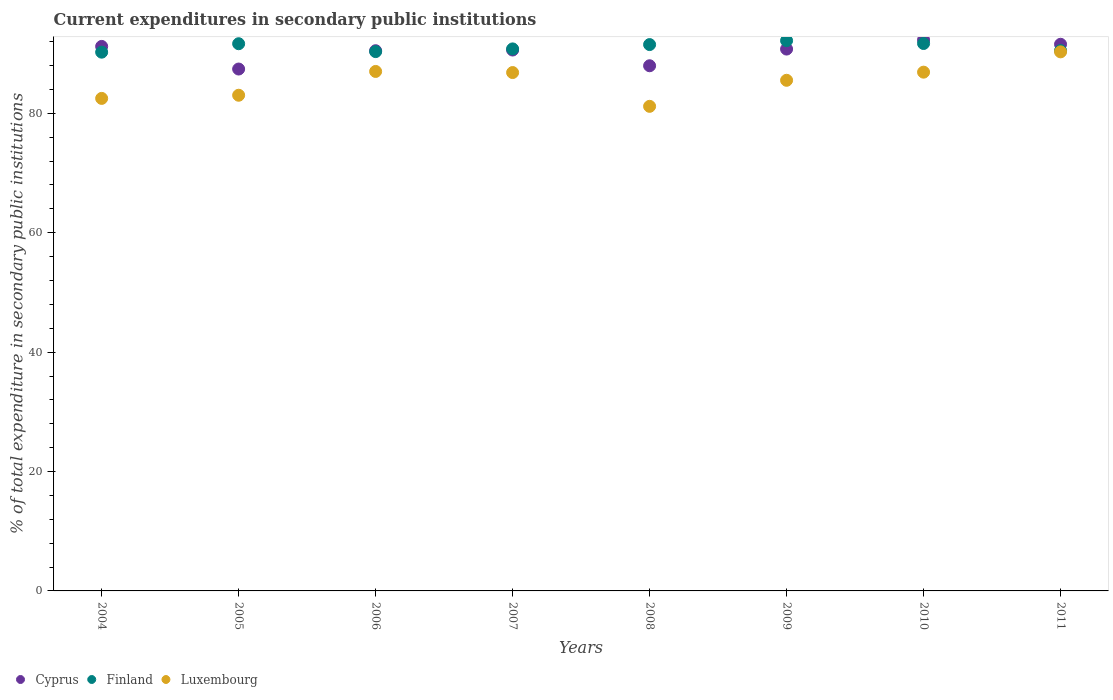Is the number of dotlines equal to the number of legend labels?
Offer a very short reply. Yes. What is the current expenditures in secondary public institutions in Luxembourg in 2008?
Keep it short and to the point. 81.17. Across all years, what is the maximum current expenditures in secondary public institutions in Luxembourg?
Offer a very short reply. 90.3. Across all years, what is the minimum current expenditures in secondary public institutions in Cyprus?
Your response must be concise. 87.42. What is the total current expenditures in secondary public institutions in Luxembourg in the graph?
Your answer should be very brief. 683.26. What is the difference between the current expenditures in secondary public institutions in Cyprus in 2010 and that in 2011?
Ensure brevity in your answer.  0.73. What is the difference between the current expenditures in secondary public institutions in Cyprus in 2004 and the current expenditures in secondary public institutions in Finland in 2009?
Provide a short and direct response. -0.97. What is the average current expenditures in secondary public institutions in Luxembourg per year?
Keep it short and to the point. 85.41. In the year 2005, what is the difference between the current expenditures in secondary public institutions in Finland and current expenditures in secondary public institutions in Luxembourg?
Your answer should be compact. 8.63. What is the ratio of the current expenditures in secondary public institutions in Luxembourg in 2005 to that in 2006?
Make the answer very short. 0.95. Is the difference between the current expenditures in secondary public institutions in Finland in 2004 and 2008 greater than the difference between the current expenditures in secondary public institutions in Luxembourg in 2004 and 2008?
Make the answer very short. No. What is the difference between the highest and the second highest current expenditures in secondary public institutions in Finland?
Provide a short and direct response. 0.48. What is the difference between the highest and the lowest current expenditures in secondary public institutions in Cyprus?
Keep it short and to the point. 4.88. In how many years, is the current expenditures in secondary public institutions in Cyprus greater than the average current expenditures in secondary public institutions in Cyprus taken over all years?
Your answer should be compact. 6. Is the sum of the current expenditures in secondary public institutions in Finland in 2008 and 2010 greater than the maximum current expenditures in secondary public institutions in Cyprus across all years?
Offer a terse response. Yes. Does the current expenditures in secondary public institutions in Cyprus monotonically increase over the years?
Keep it short and to the point. No. Is the current expenditures in secondary public institutions in Cyprus strictly greater than the current expenditures in secondary public institutions in Luxembourg over the years?
Make the answer very short. Yes. What is the difference between two consecutive major ticks on the Y-axis?
Ensure brevity in your answer.  20. Are the values on the major ticks of Y-axis written in scientific E-notation?
Offer a terse response. No. How many legend labels are there?
Your response must be concise. 3. What is the title of the graph?
Provide a short and direct response. Current expenditures in secondary public institutions. Does "Algeria" appear as one of the legend labels in the graph?
Your answer should be compact. No. What is the label or title of the X-axis?
Keep it short and to the point. Years. What is the label or title of the Y-axis?
Offer a terse response. % of total expenditure in secondary public institutions. What is the % of total expenditure in secondary public institutions of Cyprus in 2004?
Offer a terse response. 91.21. What is the % of total expenditure in secondary public institutions in Finland in 2004?
Offer a terse response. 90.24. What is the % of total expenditure in secondary public institutions in Luxembourg in 2004?
Offer a terse response. 82.5. What is the % of total expenditure in secondary public institutions of Cyprus in 2005?
Your answer should be very brief. 87.42. What is the % of total expenditure in secondary public institutions in Finland in 2005?
Ensure brevity in your answer.  91.66. What is the % of total expenditure in secondary public institutions of Luxembourg in 2005?
Your answer should be compact. 83.03. What is the % of total expenditure in secondary public institutions in Cyprus in 2006?
Make the answer very short. 90.49. What is the % of total expenditure in secondary public institutions in Finland in 2006?
Your response must be concise. 90.34. What is the % of total expenditure in secondary public institutions of Luxembourg in 2006?
Keep it short and to the point. 87.01. What is the % of total expenditure in secondary public institutions in Cyprus in 2007?
Ensure brevity in your answer.  90.6. What is the % of total expenditure in secondary public institutions in Finland in 2007?
Your response must be concise. 90.79. What is the % of total expenditure in secondary public institutions in Luxembourg in 2007?
Offer a terse response. 86.83. What is the % of total expenditure in secondary public institutions of Cyprus in 2008?
Keep it short and to the point. 87.97. What is the % of total expenditure in secondary public institutions in Finland in 2008?
Give a very brief answer. 91.51. What is the % of total expenditure in secondary public institutions of Luxembourg in 2008?
Provide a short and direct response. 81.17. What is the % of total expenditure in secondary public institutions in Cyprus in 2009?
Your answer should be compact. 90.76. What is the % of total expenditure in secondary public institutions of Finland in 2009?
Your response must be concise. 92.17. What is the % of total expenditure in secondary public institutions in Luxembourg in 2009?
Ensure brevity in your answer.  85.53. What is the % of total expenditure in secondary public institutions of Cyprus in 2010?
Ensure brevity in your answer.  92.3. What is the % of total expenditure in secondary public institutions in Finland in 2010?
Keep it short and to the point. 91.69. What is the % of total expenditure in secondary public institutions of Luxembourg in 2010?
Your answer should be compact. 86.89. What is the % of total expenditure in secondary public institutions in Cyprus in 2011?
Provide a succinct answer. 91.57. What is the % of total expenditure in secondary public institutions of Finland in 2011?
Provide a short and direct response. 90.51. What is the % of total expenditure in secondary public institutions in Luxembourg in 2011?
Give a very brief answer. 90.3. Across all years, what is the maximum % of total expenditure in secondary public institutions of Cyprus?
Offer a terse response. 92.3. Across all years, what is the maximum % of total expenditure in secondary public institutions of Finland?
Your answer should be compact. 92.17. Across all years, what is the maximum % of total expenditure in secondary public institutions of Luxembourg?
Ensure brevity in your answer.  90.3. Across all years, what is the minimum % of total expenditure in secondary public institutions in Cyprus?
Your answer should be very brief. 87.42. Across all years, what is the minimum % of total expenditure in secondary public institutions of Finland?
Provide a succinct answer. 90.24. Across all years, what is the minimum % of total expenditure in secondary public institutions in Luxembourg?
Offer a very short reply. 81.17. What is the total % of total expenditure in secondary public institutions in Cyprus in the graph?
Offer a very short reply. 722.3. What is the total % of total expenditure in secondary public institutions of Finland in the graph?
Offer a very short reply. 728.92. What is the total % of total expenditure in secondary public institutions in Luxembourg in the graph?
Your response must be concise. 683.26. What is the difference between the % of total expenditure in secondary public institutions of Cyprus in 2004 and that in 2005?
Your answer should be very brief. 3.79. What is the difference between the % of total expenditure in secondary public institutions of Finland in 2004 and that in 2005?
Offer a very short reply. -1.41. What is the difference between the % of total expenditure in secondary public institutions of Luxembourg in 2004 and that in 2005?
Keep it short and to the point. -0.53. What is the difference between the % of total expenditure in secondary public institutions of Cyprus in 2004 and that in 2006?
Ensure brevity in your answer.  0.72. What is the difference between the % of total expenditure in secondary public institutions of Finland in 2004 and that in 2006?
Your answer should be very brief. -0.09. What is the difference between the % of total expenditure in secondary public institutions in Luxembourg in 2004 and that in 2006?
Offer a very short reply. -4.51. What is the difference between the % of total expenditure in secondary public institutions in Cyprus in 2004 and that in 2007?
Provide a succinct answer. 0.6. What is the difference between the % of total expenditure in secondary public institutions in Finland in 2004 and that in 2007?
Keep it short and to the point. -0.55. What is the difference between the % of total expenditure in secondary public institutions in Luxembourg in 2004 and that in 2007?
Your response must be concise. -4.33. What is the difference between the % of total expenditure in secondary public institutions of Cyprus in 2004 and that in 2008?
Your response must be concise. 3.24. What is the difference between the % of total expenditure in secondary public institutions of Finland in 2004 and that in 2008?
Offer a very short reply. -1.27. What is the difference between the % of total expenditure in secondary public institutions in Luxembourg in 2004 and that in 2008?
Provide a short and direct response. 1.33. What is the difference between the % of total expenditure in secondary public institutions in Cyprus in 2004 and that in 2009?
Keep it short and to the point. 0.44. What is the difference between the % of total expenditure in secondary public institutions of Finland in 2004 and that in 2009?
Offer a terse response. -1.93. What is the difference between the % of total expenditure in secondary public institutions of Luxembourg in 2004 and that in 2009?
Your answer should be compact. -3.03. What is the difference between the % of total expenditure in secondary public institutions of Cyprus in 2004 and that in 2010?
Your response must be concise. -1.09. What is the difference between the % of total expenditure in secondary public institutions in Finland in 2004 and that in 2010?
Your answer should be very brief. -1.45. What is the difference between the % of total expenditure in secondary public institutions of Luxembourg in 2004 and that in 2010?
Make the answer very short. -4.4. What is the difference between the % of total expenditure in secondary public institutions in Cyprus in 2004 and that in 2011?
Ensure brevity in your answer.  -0.36. What is the difference between the % of total expenditure in secondary public institutions in Finland in 2004 and that in 2011?
Your answer should be very brief. -0.27. What is the difference between the % of total expenditure in secondary public institutions of Luxembourg in 2004 and that in 2011?
Your answer should be very brief. -7.8. What is the difference between the % of total expenditure in secondary public institutions in Cyprus in 2005 and that in 2006?
Make the answer very short. -3.07. What is the difference between the % of total expenditure in secondary public institutions of Finland in 2005 and that in 2006?
Provide a succinct answer. 1.32. What is the difference between the % of total expenditure in secondary public institutions of Luxembourg in 2005 and that in 2006?
Keep it short and to the point. -3.99. What is the difference between the % of total expenditure in secondary public institutions of Cyprus in 2005 and that in 2007?
Your answer should be compact. -3.18. What is the difference between the % of total expenditure in secondary public institutions of Finland in 2005 and that in 2007?
Ensure brevity in your answer.  0.87. What is the difference between the % of total expenditure in secondary public institutions of Luxembourg in 2005 and that in 2007?
Offer a terse response. -3.8. What is the difference between the % of total expenditure in secondary public institutions of Cyprus in 2005 and that in 2008?
Offer a very short reply. -0.55. What is the difference between the % of total expenditure in secondary public institutions of Finland in 2005 and that in 2008?
Provide a short and direct response. 0.14. What is the difference between the % of total expenditure in secondary public institutions in Luxembourg in 2005 and that in 2008?
Ensure brevity in your answer.  1.86. What is the difference between the % of total expenditure in secondary public institutions in Cyprus in 2005 and that in 2009?
Your answer should be compact. -3.34. What is the difference between the % of total expenditure in secondary public institutions in Finland in 2005 and that in 2009?
Your answer should be compact. -0.52. What is the difference between the % of total expenditure in secondary public institutions in Luxembourg in 2005 and that in 2009?
Your answer should be compact. -2.5. What is the difference between the % of total expenditure in secondary public institutions in Cyprus in 2005 and that in 2010?
Your answer should be compact. -4.88. What is the difference between the % of total expenditure in secondary public institutions in Finland in 2005 and that in 2010?
Offer a terse response. -0.04. What is the difference between the % of total expenditure in secondary public institutions in Luxembourg in 2005 and that in 2010?
Keep it short and to the point. -3.87. What is the difference between the % of total expenditure in secondary public institutions of Cyprus in 2005 and that in 2011?
Keep it short and to the point. -4.15. What is the difference between the % of total expenditure in secondary public institutions of Finland in 2005 and that in 2011?
Offer a terse response. 1.15. What is the difference between the % of total expenditure in secondary public institutions in Luxembourg in 2005 and that in 2011?
Your answer should be compact. -7.27. What is the difference between the % of total expenditure in secondary public institutions in Cyprus in 2006 and that in 2007?
Ensure brevity in your answer.  -0.11. What is the difference between the % of total expenditure in secondary public institutions in Finland in 2006 and that in 2007?
Your answer should be compact. -0.45. What is the difference between the % of total expenditure in secondary public institutions of Luxembourg in 2006 and that in 2007?
Ensure brevity in your answer.  0.19. What is the difference between the % of total expenditure in secondary public institutions of Cyprus in 2006 and that in 2008?
Give a very brief answer. 2.52. What is the difference between the % of total expenditure in secondary public institutions in Finland in 2006 and that in 2008?
Keep it short and to the point. -1.18. What is the difference between the % of total expenditure in secondary public institutions of Luxembourg in 2006 and that in 2008?
Give a very brief answer. 5.84. What is the difference between the % of total expenditure in secondary public institutions of Cyprus in 2006 and that in 2009?
Provide a short and direct response. -0.28. What is the difference between the % of total expenditure in secondary public institutions in Finland in 2006 and that in 2009?
Provide a succinct answer. -1.84. What is the difference between the % of total expenditure in secondary public institutions in Luxembourg in 2006 and that in 2009?
Offer a terse response. 1.48. What is the difference between the % of total expenditure in secondary public institutions in Cyprus in 2006 and that in 2010?
Your response must be concise. -1.81. What is the difference between the % of total expenditure in secondary public institutions of Finland in 2006 and that in 2010?
Your response must be concise. -1.36. What is the difference between the % of total expenditure in secondary public institutions in Luxembourg in 2006 and that in 2010?
Give a very brief answer. 0.12. What is the difference between the % of total expenditure in secondary public institutions in Cyprus in 2006 and that in 2011?
Your answer should be compact. -1.08. What is the difference between the % of total expenditure in secondary public institutions in Finland in 2006 and that in 2011?
Your response must be concise. -0.18. What is the difference between the % of total expenditure in secondary public institutions in Luxembourg in 2006 and that in 2011?
Provide a short and direct response. -3.28. What is the difference between the % of total expenditure in secondary public institutions in Cyprus in 2007 and that in 2008?
Ensure brevity in your answer.  2.64. What is the difference between the % of total expenditure in secondary public institutions in Finland in 2007 and that in 2008?
Provide a short and direct response. -0.72. What is the difference between the % of total expenditure in secondary public institutions in Luxembourg in 2007 and that in 2008?
Your answer should be compact. 5.66. What is the difference between the % of total expenditure in secondary public institutions of Cyprus in 2007 and that in 2009?
Offer a terse response. -0.16. What is the difference between the % of total expenditure in secondary public institutions of Finland in 2007 and that in 2009?
Offer a terse response. -1.38. What is the difference between the % of total expenditure in secondary public institutions of Luxembourg in 2007 and that in 2009?
Keep it short and to the point. 1.29. What is the difference between the % of total expenditure in secondary public institutions in Cyprus in 2007 and that in 2010?
Make the answer very short. -1.7. What is the difference between the % of total expenditure in secondary public institutions of Finland in 2007 and that in 2010?
Your answer should be very brief. -0.9. What is the difference between the % of total expenditure in secondary public institutions in Luxembourg in 2007 and that in 2010?
Provide a short and direct response. -0.07. What is the difference between the % of total expenditure in secondary public institutions in Cyprus in 2007 and that in 2011?
Ensure brevity in your answer.  -0.96. What is the difference between the % of total expenditure in secondary public institutions in Finland in 2007 and that in 2011?
Make the answer very short. 0.28. What is the difference between the % of total expenditure in secondary public institutions of Luxembourg in 2007 and that in 2011?
Make the answer very short. -3.47. What is the difference between the % of total expenditure in secondary public institutions of Cyprus in 2008 and that in 2009?
Make the answer very short. -2.8. What is the difference between the % of total expenditure in secondary public institutions of Finland in 2008 and that in 2009?
Keep it short and to the point. -0.66. What is the difference between the % of total expenditure in secondary public institutions in Luxembourg in 2008 and that in 2009?
Keep it short and to the point. -4.36. What is the difference between the % of total expenditure in secondary public institutions in Cyprus in 2008 and that in 2010?
Provide a succinct answer. -4.33. What is the difference between the % of total expenditure in secondary public institutions in Finland in 2008 and that in 2010?
Make the answer very short. -0.18. What is the difference between the % of total expenditure in secondary public institutions of Luxembourg in 2008 and that in 2010?
Provide a succinct answer. -5.72. What is the difference between the % of total expenditure in secondary public institutions of Cyprus in 2008 and that in 2011?
Make the answer very short. -3.6. What is the difference between the % of total expenditure in secondary public institutions in Luxembourg in 2008 and that in 2011?
Your answer should be very brief. -9.12. What is the difference between the % of total expenditure in secondary public institutions in Cyprus in 2009 and that in 2010?
Provide a succinct answer. -1.54. What is the difference between the % of total expenditure in secondary public institutions in Finland in 2009 and that in 2010?
Keep it short and to the point. 0.48. What is the difference between the % of total expenditure in secondary public institutions of Luxembourg in 2009 and that in 2010?
Your answer should be compact. -1.36. What is the difference between the % of total expenditure in secondary public institutions in Cyprus in 2009 and that in 2011?
Your answer should be very brief. -0.8. What is the difference between the % of total expenditure in secondary public institutions of Finland in 2009 and that in 2011?
Your response must be concise. 1.66. What is the difference between the % of total expenditure in secondary public institutions in Luxembourg in 2009 and that in 2011?
Ensure brevity in your answer.  -4.76. What is the difference between the % of total expenditure in secondary public institutions of Cyprus in 2010 and that in 2011?
Give a very brief answer. 0.73. What is the difference between the % of total expenditure in secondary public institutions in Finland in 2010 and that in 2011?
Offer a terse response. 1.18. What is the difference between the % of total expenditure in secondary public institutions in Luxembourg in 2010 and that in 2011?
Keep it short and to the point. -3.4. What is the difference between the % of total expenditure in secondary public institutions in Cyprus in 2004 and the % of total expenditure in secondary public institutions in Finland in 2005?
Make the answer very short. -0.45. What is the difference between the % of total expenditure in secondary public institutions in Cyprus in 2004 and the % of total expenditure in secondary public institutions in Luxembourg in 2005?
Your answer should be compact. 8.18. What is the difference between the % of total expenditure in secondary public institutions of Finland in 2004 and the % of total expenditure in secondary public institutions of Luxembourg in 2005?
Keep it short and to the point. 7.22. What is the difference between the % of total expenditure in secondary public institutions of Cyprus in 2004 and the % of total expenditure in secondary public institutions of Finland in 2006?
Your answer should be very brief. 0.87. What is the difference between the % of total expenditure in secondary public institutions of Cyprus in 2004 and the % of total expenditure in secondary public institutions of Luxembourg in 2006?
Provide a succinct answer. 4.19. What is the difference between the % of total expenditure in secondary public institutions in Finland in 2004 and the % of total expenditure in secondary public institutions in Luxembourg in 2006?
Provide a succinct answer. 3.23. What is the difference between the % of total expenditure in secondary public institutions in Cyprus in 2004 and the % of total expenditure in secondary public institutions in Finland in 2007?
Your response must be concise. 0.42. What is the difference between the % of total expenditure in secondary public institutions in Cyprus in 2004 and the % of total expenditure in secondary public institutions in Luxembourg in 2007?
Make the answer very short. 4.38. What is the difference between the % of total expenditure in secondary public institutions in Finland in 2004 and the % of total expenditure in secondary public institutions in Luxembourg in 2007?
Provide a succinct answer. 3.42. What is the difference between the % of total expenditure in secondary public institutions of Cyprus in 2004 and the % of total expenditure in secondary public institutions of Finland in 2008?
Make the answer very short. -0.31. What is the difference between the % of total expenditure in secondary public institutions of Cyprus in 2004 and the % of total expenditure in secondary public institutions of Luxembourg in 2008?
Ensure brevity in your answer.  10.04. What is the difference between the % of total expenditure in secondary public institutions in Finland in 2004 and the % of total expenditure in secondary public institutions in Luxembourg in 2008?
Give a very brief answer. 9.07. What is the difference between the % of total expenditure in secondary public institutions of Cyprus in 2004 and the % of total expenditure in secondary public institutions of Finland in 2009?
Your answer should be very brief. -0.97. What is the difference between the % of total expenditure in secondary public institutions of Cyprus in 2004 and the % of total expenditure in secondary public institutions of Luxembourg in 2009?
Make the answer very short. 5.67. What is the difference between the % of total expenditure in secondary public institutions in Finland in 2004 and the % of total expenditure in secondary public institutions in Luxembourg in 2009?
Your response must be concise. 4.71. What is the difference between the % of total expenditure in secondary public institutions of Cyprus in 2004 and the % of total expenditure in secondary public institutions of Finland in 2010?
Provide a succinct answer. -0.49. What is the difference between the % of total expenditure in secondary public institutions of Cyprus in 2004 and the % of total expenditure in secondary public institutions of Luxembourg in 2010?
Provide a short and direct response. 4.31. What is the difference between the % of total expenditure in secondary public institutions in Finland in 2004 and the % of total expenditure in secondary public institutions in Luxembourg in 2010?
Provide a succinct answer. 3.35. What is the difference between the % of total expenditure in secondary public institutions in Cyprus in 2004 and the % of total expenditure in secondary public institutions in Finland in 2011?
Ensure brevity in your answer.  0.69. What is the difference between the % of total expenditure in secondary public institutions of Cyprus in 2004 and the % of total expenditure in secondary public institutions of Luxembourg in 2011?
Make the answer very short. 0.91. What is the difference between the % of total expenditure in secondary public institutions of Finland in 2004 and the % of total expenditure in secondary public institutions of Luxembourg in 2011?
Provide a short and direct response. -0.05. What is the difference between the % of total expenditure in secondary public institutions in Cyprus in 2005 and the % of total expenditure in secondary public institutions in Finland in 2006?
Provide a succinct answer. -2.92. What is the difference between the % of total expenditure in secondary public institutions of Cyprus in 2005 and the % of total expenditure in secondary public institutions of Luxembourg in 2006?
Ensure brevity in your answer.  0.4. What is the difference between the % of total expenditure in secondary public institutions of Finland in 2005 and the % of total expenditure in secondary public institutions of Luxembourg in 2006?
Provide a short and direct response. 4.64. What is the difference between the % of total expenditure in secondary public institutions in Cyprus in 2005 and the % of total expenditure in secondary public institutions in Finland in 2007?
Offer a terse response. -3.37. What is the difference between the % of total expenditure in secondary public institutions of Cyprus in 2005 and the % of total expenditure in secondary public institutions of Luxembourg in 2007?
Your answer should be compact. 0.59. What is the difference between the % of total expenditure in secondary public institutions in Finland in 2005 and the % of total expenditure in secondary public institutions in Luxembourg in 2007?
Give a very brief answer. 4.83. What is the difference between the % of total expenditure in secondary public institutions of Cyprus in 2005 and the % of total expenditure in secondary public institutions of Finland in 2008?
Offer a very short reply. -4.1. What is the difference between the % of total expenditure in secondary public institutions in Cyprus in 2005 and the % of total expenditure in secondary public institutions in Luxembourg in 2008?
Offer a terse response. 6.25. What is the difference between the % of total expenditure in secondary public institutions in Finland in 2005 and the % of total expenditure in secondary public institutions in Luxembourg in 2008?
Your answer should be compact. 10.49. What is the difference between the % of total expenditure in secondary public institutions of Cyprus in 2005 and the % of total expenditure in secondary public institutions of Finland in 2009?
Your response must be concise. -4.75. What is the difference between the % of total expenditure in secondary public institutions of Cyprus in 2005 and the % of total expenditure in secondary public institutions of Luxembourg in 2009?
Offer a very short reply. 1.89. What is the difference between the % of total expenditure in secondary public institutions in Finland in 2005 and the % of total expenditure in secondary public institutions in Luxembourg in 2009?
Make the answer very short. 6.12. What is the difference between the % of total expenditure in secondary public institutions in Cyprus in 2005 and the % of total expenditure in secondary public institutions in Finland in 2010?
Provide a short and direct response. -4.28. What is the difference between the % of total expenditure in secondary public institutions of Cyprus in 2005 and the % of total expenditure in secondary public institutions of Luxembourg in 2010?
Your response must be concise. 0.52. What is the difference between the % of total expenditure in secondary public institutions in Finland in 2005 and the % of total expenditure in secondary public institutions in Luxembourg in 2010?
Keep it short and to the point. 4.76. What is the difference between the % of total expenditure in secondary public institutions in Cyprus in 2005 and the % of total expenditure in secondary public institutions in Finland in 2011?
Provide a succinct answer. -3.09. What is the difference between the % of total expenditure in secondary public institutions in Cyprus in 2005 and the % of total expenditure in secondary public institutions in Luxembourg in 2011?
Your response must be concise. -2.88. What is the difference between the % of total expenditure in secondary public institutions of Finland in 2005 and the % of total expenditure in secondary public institutions of Luxembourg in 2011?
Ensure brevity in your answer.  1.36. What is the difference between the % of total expenditure in secondary public institutions of Cyprus in 2006 and the % of total expenditure in secondary public institutions of Finland in 2007?
Keep it short and to the point. -0.3. What is the difference between the % of total expenditure in secondary public institutions of Cyprus in 2006 and the % of total expenditure in secondary public institutions of Luxembourg in 2007?
Offer a terse response. 3.66. What is the difference between the % of total expenditure in secondary public institutions of Finland in 2006 and the % of total expenditure in secondary public institutions of Luxembourg in 2007?
Your response must be concise. 3.51. What is the difference between the % of total expenditure in secondary public institutions in Cyprus in 2006 and the % of total expenditure in secondary public institutions in Finland in 2008?
Ensure brevity in your answer.  -1.03. What is the difference between the % of total expenditure in secondary public institutions in Cyprus in 2006 and the % of total expenditure in secondary public institutions in Luxembourg in 2008?
Make the answer very short. 9.32. What is the difference between the % of total expenditure in secondary public institutions of Finland in 2006 and the % of total expenditure in secondary public institutions of Luxembourg in 2008?
Give a very brief answer. 9.17. What is the difference between the % of total expenditure in secondary public institutions of Cyprus in 2006 and the % of total expenditure in secondary public institutions of Finland in 2009?
Offer a very short reply. -1.69. What is the difference between the % of total expenditure in secondary public institutions in Cyprus in 2006 and the % of total expenditure in secondary public institutions in Luxembourg in 2009?
Give a very brief answer. 4.95. What is the difference between the % of total expenditure in secondary public institutions in Finland in 2006 and the % of total expenditure in secondary public institutions in Luxembourg in 2009?
Your answer should be very brief. 4.8. What is the difference between the % of total expenditure in secondary public institutions in Cyprus in 2006 and the % of total expenditure in secondary public institutions in Finland in 2010?
Provide a succinct answer. -1.21. What is the difference between the % of total expenditure in secondary public institutions in Cyprus in 2006 and the % of total expenditure in secondary public institutions in Luxembourg in 2010?
Make the answer very short. 3.59. What is the difference between the % of total expenditure in secondary public institutions in Finland in 2006 and the % of total expenditure in secondary public institutions in Luxembourg in 2010?
Offer a very short reply. 3.44. What is the difference between the % of total expenditure in secondary public institutions of Cyprus in 2006 and the % of total expenditure in secondary public institutions of Finland in 2011?
Your answer should be very brief. -0.03. What is the difference between the % of total expenditure in secondary public institutions of Cyprus in 2006 and the % of total expenditure in secondary public institutions of Luxembourg in 2011?
Keep it short and to the point. 0.19. What is the difference between the % of total expenditure in secondary public institutions in Finland in 2006 and the % of total expenditure in secondary public institutions in Luxembourg in 2011?
Your answer should be very brief. 0.04. What is the difference between the % of total expenditure in secondary public institutions in Cyprus in 2007 and the % of total expenditure in secondary public institutions in Finland in 2008?
Ensure brevity in your answer.  -0.91. What is the difference between the % of total expenditure in secondary public institutions in Cyprus in 2007 and the % of total expenditure in secondary public institutions in Luxembourg in 2008?
Provide a short and direct response. 9.43. What is the difference between the % of total expenditure in secondary public institutions of Finland in 2007 and the % of total expenditure in secondary public institutions of Luxembourg in 2008?
Your answer should be very brief. 9.62. What is the difference between the % of total expenditure in secondary public institutions of Cyprus in 2007 and the % of total expenditure in secondary public institutions of Finland in 2009?
Give a very brief answer. -1.57. What is the difference between the % of total expenditure in secondary public institutions in Cyprus in 2007 and the % of total expenditure in secondary public institutions in Luxembourg in 2009?
Give a very brief answer. 5.07. What is the difference between the % of total expenditure in secondary public institutions of Finland in 2007 and the % of total expenditure in secondary public institutions of Luxembourg in 2009?
Offer a very short reply. 5.26. What is the difference between the % of total expenditure in secondary public institutions of Cyprus in 2007 and the % of total expenditure in secondary public institutions of Finland in 2010?
Offer a very short reply. -1.09. What is the difference between the % of total expenditure in secondary public institutions of Cyprus in 2007 and the % of total expenditure in secondary public institutions of Luxembourg in 2010?
Provide a short and direct response. 3.71. What is the difference between the % of total expenditure in secondary public institutions of Finland in 2007 and the % of total expenditure in secondary public institutions of Luxembourg in 2010?
Provide a short and direct response. 3.9. What is the difference between the % of total expenditure in secondary public institutions in Cyprus in 2007 and the % of total expenditure in secondary public institutions in Finland in 2011?
Offer a terse response. 0.09. What is the difference between the % of total expenditure in secondary public institutions of Cyprus in 2007 and the % of total expenditure in secondary public institutions of Luxembourg in 2011?
Provide a short and direct response. 0.31. What is the difference between the % of total expenditure in secondary public institutions of Finland in 2007 and the % of total expenditure in secondary public institutions of Luxembourg in 2011?
Your response must be concise. 0.49. What is the difference between the % of total expenditure in secondary public institutions of Cyprus in 2008 and the % of total expenditure in secondary public institutions of Finland in 2009?
Your answer should be very brief. -4.21. What is the difference between the % of total expenditure in secondary public institutions in Cyprus in 2008 and the % of total expenditure in secondary public institutions in Luxembourg in 2009?
Make the answer very short. 2.43. What is the difference between the % of total expenditure in secondary public institutions of Finland in 2008 and the % of total expenditure in secondary public institutions of Luxembourg in 2009?
Offer a very short reply. 5.98. What is the difference between the % of total expenditure in secondary public institutions in Cyprus in 2008 and the % of total expenditure in secondary public institutions in Finland in 2010?
Your answer should be very brief. -3.73. What is the difference between the % of total expenditure in secondary public institutions in Cyprus in 2008 and the % of total expenditure in secondary public institutions in Luxembourg in 2010?
Your answer should be compact. 1.07. What is the difference between the % of total expenditure in secondary public institutions in Finland in 2008 and the % of total expenditure in secondary public institutions in Luxembourg in 2010?
Your answer should be very brief. 4.62. What is the difference between the % of total expenditure in secondary public institutions in Cyprus in 2008 and the % of total expenditure in secondary public institutions in Finland in 2011?
Provide a succinct answer. -2.55. What is the difference between the % of total expenditure in secondary public institutions of Cyprus in 2008 and the % of total expenditure in secondary public institutions of Luxembourg in 2011?
Give a very brief answer. -2.33. What is the difference between the % of total expenditure in secondary public institutions of Finland in 2008 and the % of total expenditure in secondary public institutions of Luxembourg in 2011?
Keep it short and to the point. 1.22. What is the difference between the % of total expenditure in secondary public institutions in Cyprus in 2009 and the % of total expenditure in secondary public institutions in Finland in 2010?
Keep it short and to the point. -0.93. What is the difference between the % of total expenditure in secondary public institutions of Cyprus in 2009 and the % of total expenditure in secondary public institutions of Luxembourg in 2010?
Offer a terse response. 3.87. What is the difference between the % of total expenditure in secondary public institutions of Finland in 2009 and the % of total expenditure in secondary public institutions of Luxembourg in 2010?
Your answer should be very brief. 5.28. What is the difference between the % of total expenditure in secondary public institutions in Cyprus in 2009 and the % of total expenditure in secondary public institutions in Finland in 2011?
Your answer should be very brief. 0.25. What is the difference between the % of total expenditure in secondary public institutions in Cyprus in 2009 and the % of total expenditure in secondary public institutions in Luxembourg in 2011?
Keep it short and to the point. 0.47. What is the difference between the % of total expenditure in secondary public institutions of Finland in 2009 and the % of total expenditure in secondary public institutions of Luxembourg in 2011?
Your response must be concise. 1.88. What is the difference between the % of total expenditure in secondary public institutions of Cyprus in 2010 and the % of total expenditure in secondary public institutions of Finland in 2011?
Provide a succinct answer. 1.79. What is the difference between the % of total expenditure in secondary public institutions in Cyprus in 2010 and the % of total expenditure in secondary public institutions in Luxembourg in 2011?
Provide a succinct answer. 2. What is the difference between the % of total expenditure in secondary public institutions in Finland in 2010 and the % of total expenditure in secondary public institutions in Luxembourg in 2011?
Your answer should be compact. 1.4. What is the average % of total expenditure in secondary public institutions of Cyprus per year?
Keep it short and to the point. 90.29. What is the average % of total expenditure in secondary public institutions in Finland per year?
Make the answer very short. 91.12. What is the average % of total expenditure in secondary public institutions in Luxembourg per year?
Make the answer very short. 85.41. In the year 2004, what is the difference between the % of total expenditure in secondary public institutions of Cyprus and % of total expenditure in secondary public institutions of Finland?
Your answer should be very brief. 0.96. In the year 2004, what is the difference between the % of total expenditure in secondary public institutions in Cyprus and % of total expenditure in secondary public institutions in Luxembourg?
Offer a terse response. 8.71. In the year 2004, what is the difference between the % of total expenditure in secondary public institutions in Finland and % of total expenditure in secondary public institutions in Luxembourg?
Your answer should be compact. 7.74. In the year 2005, what is the difference between the % of total expenditure in secondary public institutions in Cyprus and % of total expenditure in secondary public institutions in Finland?
Make the answer very short. -4.24. In the year 2005, what is the difference between the % of total expenditure in secondary public institutions in Cyprus and % of total expenditure in secondary public institutions in Luxembourg?
Your response must be concise. 4.39. In the year 2005, what is the difference between the % of total expenditure in secondary public institutions of Finland and % of total expenditure in secondary public institutions of Luxembourg?
Your response must be concise. 8.63. In the year 2006, what is the difference between the % of total expenditure in secondary public institutions in Cyprus and % of total expenditure in secondary public institutions in Finland?
Make the answer very short. 0.15. In the year 2006, what is the difference between the % of total expenditure in secondary public institutions of Cyprus and % of total expenditure in secondary public institutions of Luxembourg?
Make the answer very short. 3.47. In the year 2006, what is the difference between the % of total expenditure in secondary public institutions of Finland and % of total expenditure in secondary public institutions of Luxembourg?
Provide a short and direct response. 3.32. In the year 2007, what is the difference between the % of total expenditure in secondary public institutions in Cyprus and % of total expenditure in secondary public institutions in Finland?
Give a very brief answer. -0.19. In the year 2007, what is the difference between the % of total expenditure in secondary public institutions of Cyprus and % of total expenditure in secondary public institutions of Luxembourg?
Ensure brevity in your answer.  3.77. In the year 2007, what is the difference between the % of total expenditure in secondary public institutions in Finland and % of total expenditure in secondary public institutions in Luxembourg?
Make the answer very short. 3.96. In the year 2008, what is the difference between the % of total expenditure in secondary public institutions of Cyprus and % of total expenditure in secondary public institutions of Finland?
Give a very brief answer. -3.55. In the year 2008, what is the difference between the % of total expenditure in secondary public institutions of Cyprus and % of total expenditure in secondary public institutions of Luxembourg?
Your response must be concise. 6.8. In the year 2008, what is the difference between the % of total expenditure in secondary public institutions in Finland and % of total expenditure in secondary public institutions in Luxembourg?
Make the answer very short. 10.34. In the year 2009, what is the difference between the % of total expenditure in secondary public institutions in Cyprus and % of total expenditure in secondary public institutions in Finland?
Make the answer very short. -1.41. In the year 2009, what is the difference between the % of total expenditure in secondary public institutions of Cyprus and % of total expenditure in secondary public institutions of Luxembourg?
Your answer should be compact. 5.23. In the year 2009, what is the difference between the % of total expenditure in secondary public institutions in Finland and % of total expenditure in secondary public institutions in Luxembourg?
Make the answer very short. 6.64. In the year 2010, what is the difference between the % of total expenditure in secondary public institutions in Cyprus and % of total expenditure in secondary public institutions in Finland?
Your answer should be compact. 0.6. In the year 2010, what is the difference between the % of total expenditure in secondary public institutions in Cyprus and % of total expenditure in secondary public institutions in Luxembourg?
Ensure brevity in your answer.  5.4. In the year 2010, what is the difference between the % of total expenditure in secondary public institutions in Finland and % of total expenditure in secondary public institutions in Luxembourg?
Your response must be concise. 4.8. In the year 2011, what is the difference between the % of total expenditure in secondary public institutions of Cyprus and % of total expenditure in secondary public institutions of Finland?
Provide a succinct answer. 1.05. In the year 2011, what is the difference between the % of total expenditure in secondary public institutions of Cyprus and % of total expenditure in secondary public institutions of Luxembourg?
Keep it short and to the point. 1.27. In the year 2011, what is the difference between the % of total expenditure in secondary public institutions in Finland and % of total expenditure in secondary public institutions in Luxembourg?
Your answer should be very brief. 0.22. What is the ratio of the % of total expenditure in secondary public institutions of Cyprus in 2004 to that in 2005?
Provide a succinct answer. 1.04. What is the ratio of the % of total expenditure in secondary public institutions of Finland in 2004 to that in 2005?
Offer a terse response. 0.98. What is the ratio of the % of total expenditure in secondary public institutions of Luxembourg in 2004 to that in 2005?
Make the answer very short. 0.99. What is the ratio of the % of total expenditure in secondary public institutions of Cyprus in 2004 to that in 2006?
Offer a terse response. 1.01. What is the ratio of the % of total expenditure in secondary public institutions of Luxembourg in 2004 to that in 2006?
Provide a succinct answer. 0.95. What is the ratio of the % of total expenditure in secondary public institutions of Cyprus in 2004 to that in 2007?
Provide a succinct answer. 1.01. What is the ratio of the % of total expenditure in secondary public institutions of Finland in 2004 to that in 2007?
Your response must be concise. 0.99. What is the ratio of the % of total expenditure in secondary public institutions in Luxembourg in 2004 to that in 2007?
Offer a terse response. 0.95. What is the ratio of the % of total expenditure in secondary public institutions of Cyprus in 2004 to that in 2008?
Make the answer very short. 1.04. What is the ratio of the % of total expenditure in secondary public institutions in Finland in 2004 to that in 2008?
Provide a short and direct response. 0.99. What is the ratio of the % of total expenditure in secondary public institutions in Luxembourg in 2004 to that in 2008?
Provide a short and direct response. 1.02. What is the ratio of the % of total expenditure in secondary public institutions in Cyprus in 2004 to that in 2009?
Give a very brief answer. 1. What is the ratio of the % of total expenditure in secondary public institutions of Finland in 2004 to that in 2009?
Your response must be concise. 0.98. What is the ratio of the % of total expenditure in secondary public institutions in Luxembourg in 2004 to that in 2009?
Offer a very short reply. 0.96. What is the ratio of the % of total expenditure in secondary public institutions in Cyprus in 2004 to that in 2010?
Your answer should be very brief. 0.99. What is the ratio of the % of total expenditure in secondary public institutions in Finland in 2004 to that in 2010?
Provide a succinct answer. 0.98. What is the ratio of the % of total expenditure in secondary public institutions in Luxembourg in 2004 to that in 2010?
Offer a terse response. 0.95. What is the ratio of the % of total expenditure in secondary public institutions of Cyprus in 2004 to that in 2011?
Offer a terse response. 1. What is the ratio of the % of total expenditure in secondary public institutions in Luxembourg in 2004 to that in 2011?
Your answer should be very brief. 0.91. What is the ratio of the % of total expenditure in secondary public institutions of Cyprus in 2005 to that in 2006?
Ensure brevity in your answer.  0.97. What is the ratio of the % of total expenditure in secondary public institutions of Finland in 2005 to that in 2006?
Your answer should be compact. 1.01. What is the ratio of the % of total expenditure in secondary public institutions of Luxembourg in 2005 to that in 2006?
Your answer should be compact. 0.95. What is the ratio of the % of total expenditure in secondary public institutions of Cyprus in 2005 to that in 2007?
Provide a succinct answer. 0.96. What is the ratio of the % of total expenditure in secondary public institutions of Finland in 2005 to that in 2007?
Ensure brevity in your answer.  1.01. What is the ratio of the % of total expenditure in secondary public institutions in Luxembourg in 2005 to that in 2007?
Your response must be concise. 0.96. What is the ratio of the % of total expenditure in secondary public institutions in Cyprus in 2005 to that in 2008?
Offer a very short reply. 0.99. What is the ratio of the % of total expenditure in secondary public institutions of Luxembourg in 2005 to that in 2008?
Provide a short and direct response. 1.02. What is the ratio of the % of total expenditure in secondary public institutions of Cyprus in 2005 to that in 2009?
Provide a succinct answer. 0.96. What is the ratio of the % of total expenditure in secondary public institutions of Finland in 2005 to that in 2009?
Your answer should be compact. 0.99. What is the ratio of the % of total expenditure in secondary public institutions in Luxembourg in 2005 to that in 2009?
Keep it short and to the point. 0.97. What is the ratio of the % of total expenditure in secondary public institutions in Cyprus in 2005 to that in 2010?
Your response must be concise. 0.95. What is the ratio of the % of total expenditure in secondary public institutions in Finland in 2005 to that in 2010?
Ensure brevity in your answer.  1. What is the ratio of the % of total expenditure in secondary public institutions of Luxembourg in 2005 to that in 2010?
Ensure brevity in your answer.  0.96. What is the ratio of the % of total expenditure in secondary public institutions in Cyprus in 2005 to that in 2011?
Give a very brief answer. 0.95. What is the ratio of the % of total expenditure in secondary public institutions of Finland in 2005 to that in 2011?
Keep it short and to the point. 1.01. What is the ratio of the % of total expenditure in secondary public institutions in Luxembourg in 2005 to that in 2011?
Provide a short and direct response. 0.92. What is the ratio of the % of total expenditure in secondary public institutions of Finland in 2006 to that in 2007?
Your answer should be compact. 0.99. What is the ratio of the % of total expenditure in secondary public institutions of Luxembourg in 2006 to that in 2007?
Your answer should be compact. 1. What is the ratio of the % of total expenditure in secondary public institutions in Cyprus in 2006 to that in 2008?
Provide a short and direct response. 1.03. What is the ratio of the % of total expenditure in secondary public institutions in Finland in 2006 to that in 2008?
Make the answer very short. 0.99. What is the ratio of the % of total expenditure in secondary public institutions in Luxembourg in 2006 to that in 2008?
Your answer should be compact. 1.07. What is the ratio of the % of total expenditure in secondary public institutions in Finland in 2006 to that in 2009?
Your answer should be very brief. 0.98. What is the ratio of the % of total expenditure in secondary public institutions of Luxembourg in 2006 to that in 2009?
Give a very brief answer. 1.02. What is the ratio of the % of total expenditure in secondary public institutions in Cyprus in 2006 to that in 2010?
Provide a succinct answer. 0.98. What is the ratio of the % of total expenditure in secondary public institutions of Finland in 2006 to that in 2010?
Offer a very short reply. 0.99. What is the ratio of the % of total expenditure in secondary public institutions of Luxembourg in 2006 to that in 2010?
Give a very brief answer. 1. What is the ratio of the % of total expenditure in secondary public institutions in Cyprus in 2006 to that in 2011?
Keep it short and to the point. 0.99. What is the ratio of the % of total expenditure in secondary public institutions in Luxembourg in 2006 to that in 2011?
Your answer should be very brief. 0.96. What is the ratio of the % of total expenditure in secondary public institutions of Cyprus in 2007 to that in 2008?
Ensure brevity in your answer.  1.03. What is the ratio of the % of total expenditure in secondary public institutions in Luxembourg in 2007 to that in 2008?
Your answer should be very brief. 1.07. What is the ratio of the % of total expenditure in secondary public institutions in Cyprus in 2007 to that in 2009?
Give a very brief answer. 1. What is the ratio of the % of total expenditure in secondary public institutions in Finland in 2007 to that in 2009?
Make the answer very short. 0.98. What is the ratio of the % of total expenditure in secondary public institutions in Luxembourg in 2007 to that in 2009?
Your answer should be very brief. 1.02. What is the ratio of the % of total expenditure in secondary public institutions of Cyprus in 2007 to that in 2010?
Give a very brief answer. 0.98. What is the ratio of the % of total expenditure in secondary public institutions of Finland in 2007 to that in 2010?
Your response must be concise. 0.99. What is the ratio of the % of total expenditure in secondary public institutions of Cyprus in 2007 to that in 2011?
Your response must be concise. 0.99. What is the ratio of the % of total expenditure in secondary public institutions of Luxembourg in 2007 to that in 2011?
Give a very brief answer. 0.96. What is the ratio of the % of total expenditure in secondary public institutions of Cyprus in 2008 to that in 2009?
Offer a terse response. 0.97. What is the ratio of the % of total expenditure in secondary public institutions of Finland in 2008 to that in 2009?
Offer a very short reply. 0.99. What is the ratio of the % of total expenditure in secondary public institutions in Luxembourg in 2008 to that in 2009?
Provide a succinct answer. 0.95. What is the ratio of the % of total expenditure in secondary public institutions of Cyprus in 2008 to that in 2010?
Your answer should be very brief. 0.95. What is the ratio of the % of total expenditure in secondary public institutions of Luxembourg in 2008 to that in 2010?
Ensure brevity in your answer.  0.93. What is the ratio of the % of total expenditure in secondary public institutions in Cyprus in 2008 to that in 2011?
Offer a very short reply. 0.96. What is the ratio of the % of total expenditure in secondary public institutions of Finland in 2008 to that in 2011?
Offer a very short reply. 1.01. What is the ratio of the % of total expenditure in secondary public institutions in Luxembourg in 2008 to that in 2011?
Your response must be concise. 0.9. What is the ratio of the % of total expenditure in secondary public institutions of Cyprus in 2009 to that in 2010?
Provide a short and direct response. 0.98. What is the ratio of the % of total expenditure in secondary public institutions of Finland in 2009 to that in 2010?
Offer a terse response. 1.01. What is the ratio of the % of total expenditure in secondary public institutions of Luxembourg in 2009 to that in 2010?
Make the answer very short. 0.98. What is the ratio of the % of total expenditure in secondary public institutions in Cyprus in 2009 to that in 2011?
Keep it short and to the point. 0.99. What is the ratio of the % of total expenditure in secondary public institutions of Finland in 2009 to that in 2011?
Provide a succinct answer. 1.02. What is the ratio of the % of total expenditure in secondary public institutions of Luxembourg in 2009 to that in 2011?
Provide a succinct answer. 0.95. What is the ratio of the % of total expenditure in secondary public institutions in Cyprus in 2010 to that in 2011?
Give a very brief answer. 1.01. What is the ratio of the % of total expenditure in secondary public institutions of Finland in 2010 to that in 2011?
Provide a short and direct response. 1.01. What is the ratio of the % of total expenditure in secondary public institutions of Luxembourg in 2010 to that in 2011?
Offer a very short reply. 0.96. What is the difference between the highest and the second highest % of total expenditure in secondary public institutions of Cyprus?
Your answer should be compact. 0.73. What is the difference between the highest and the second highest % of total expenditure in secondary public institutions of Finland?
Give a very brief answer. 0.48. What is the difference between the highest and the second highest % of total expenditure in secondary public institutions of Luxembourg?
Keep it short and to the point. 3.28. What is the difference between the highest and the lowest % of total expenditure in secondary public institutions of Cyprus?
Keep it short and to the point. 4.88. What is the difference between the highest and the lowest % of total expenditure in secondary public institutions in Finland?
Keep it short and to the point. 1.93. What is the difference between the highest and the lowest % of total expenditure in secondary public institutions in Luxembourg?
Ensure brevity in your answer.  9.12. 